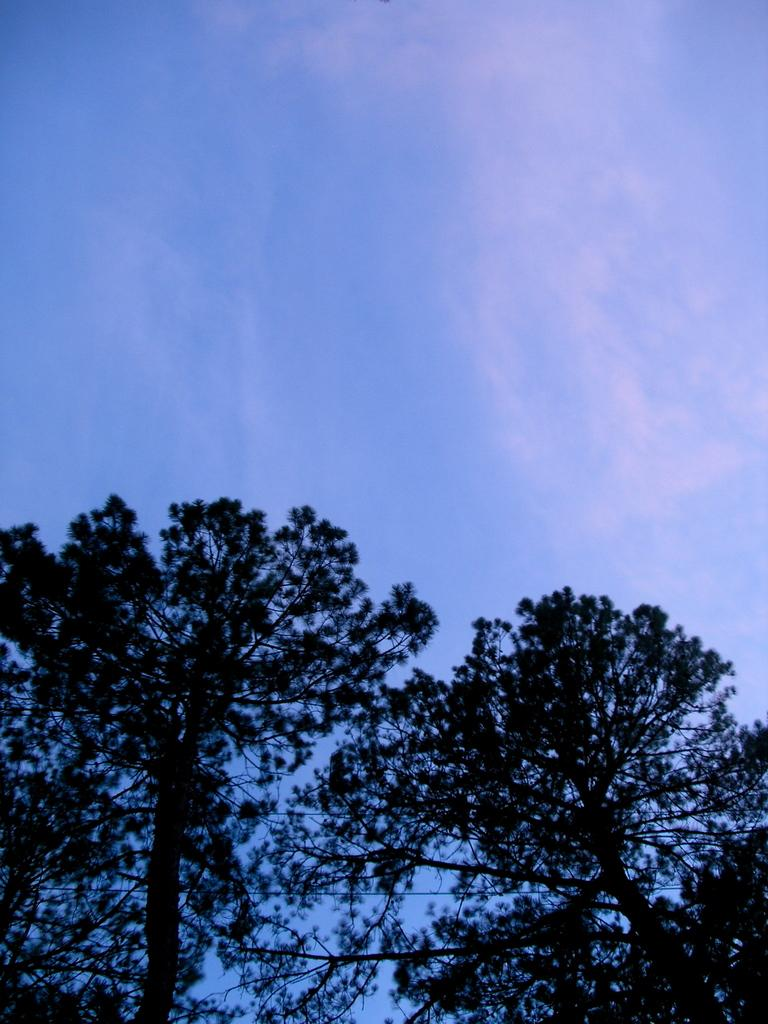What type of vegetation can be seen in the image? There are trees in the image. What part of the natural environment is visible in the image? The sky is visible in the background of the image. What type of downtown area can be seen in the image? There is no downtown area present in the image; it features trees and the sky. What form does the hot object take in the image? There is no hot object present in the image. 